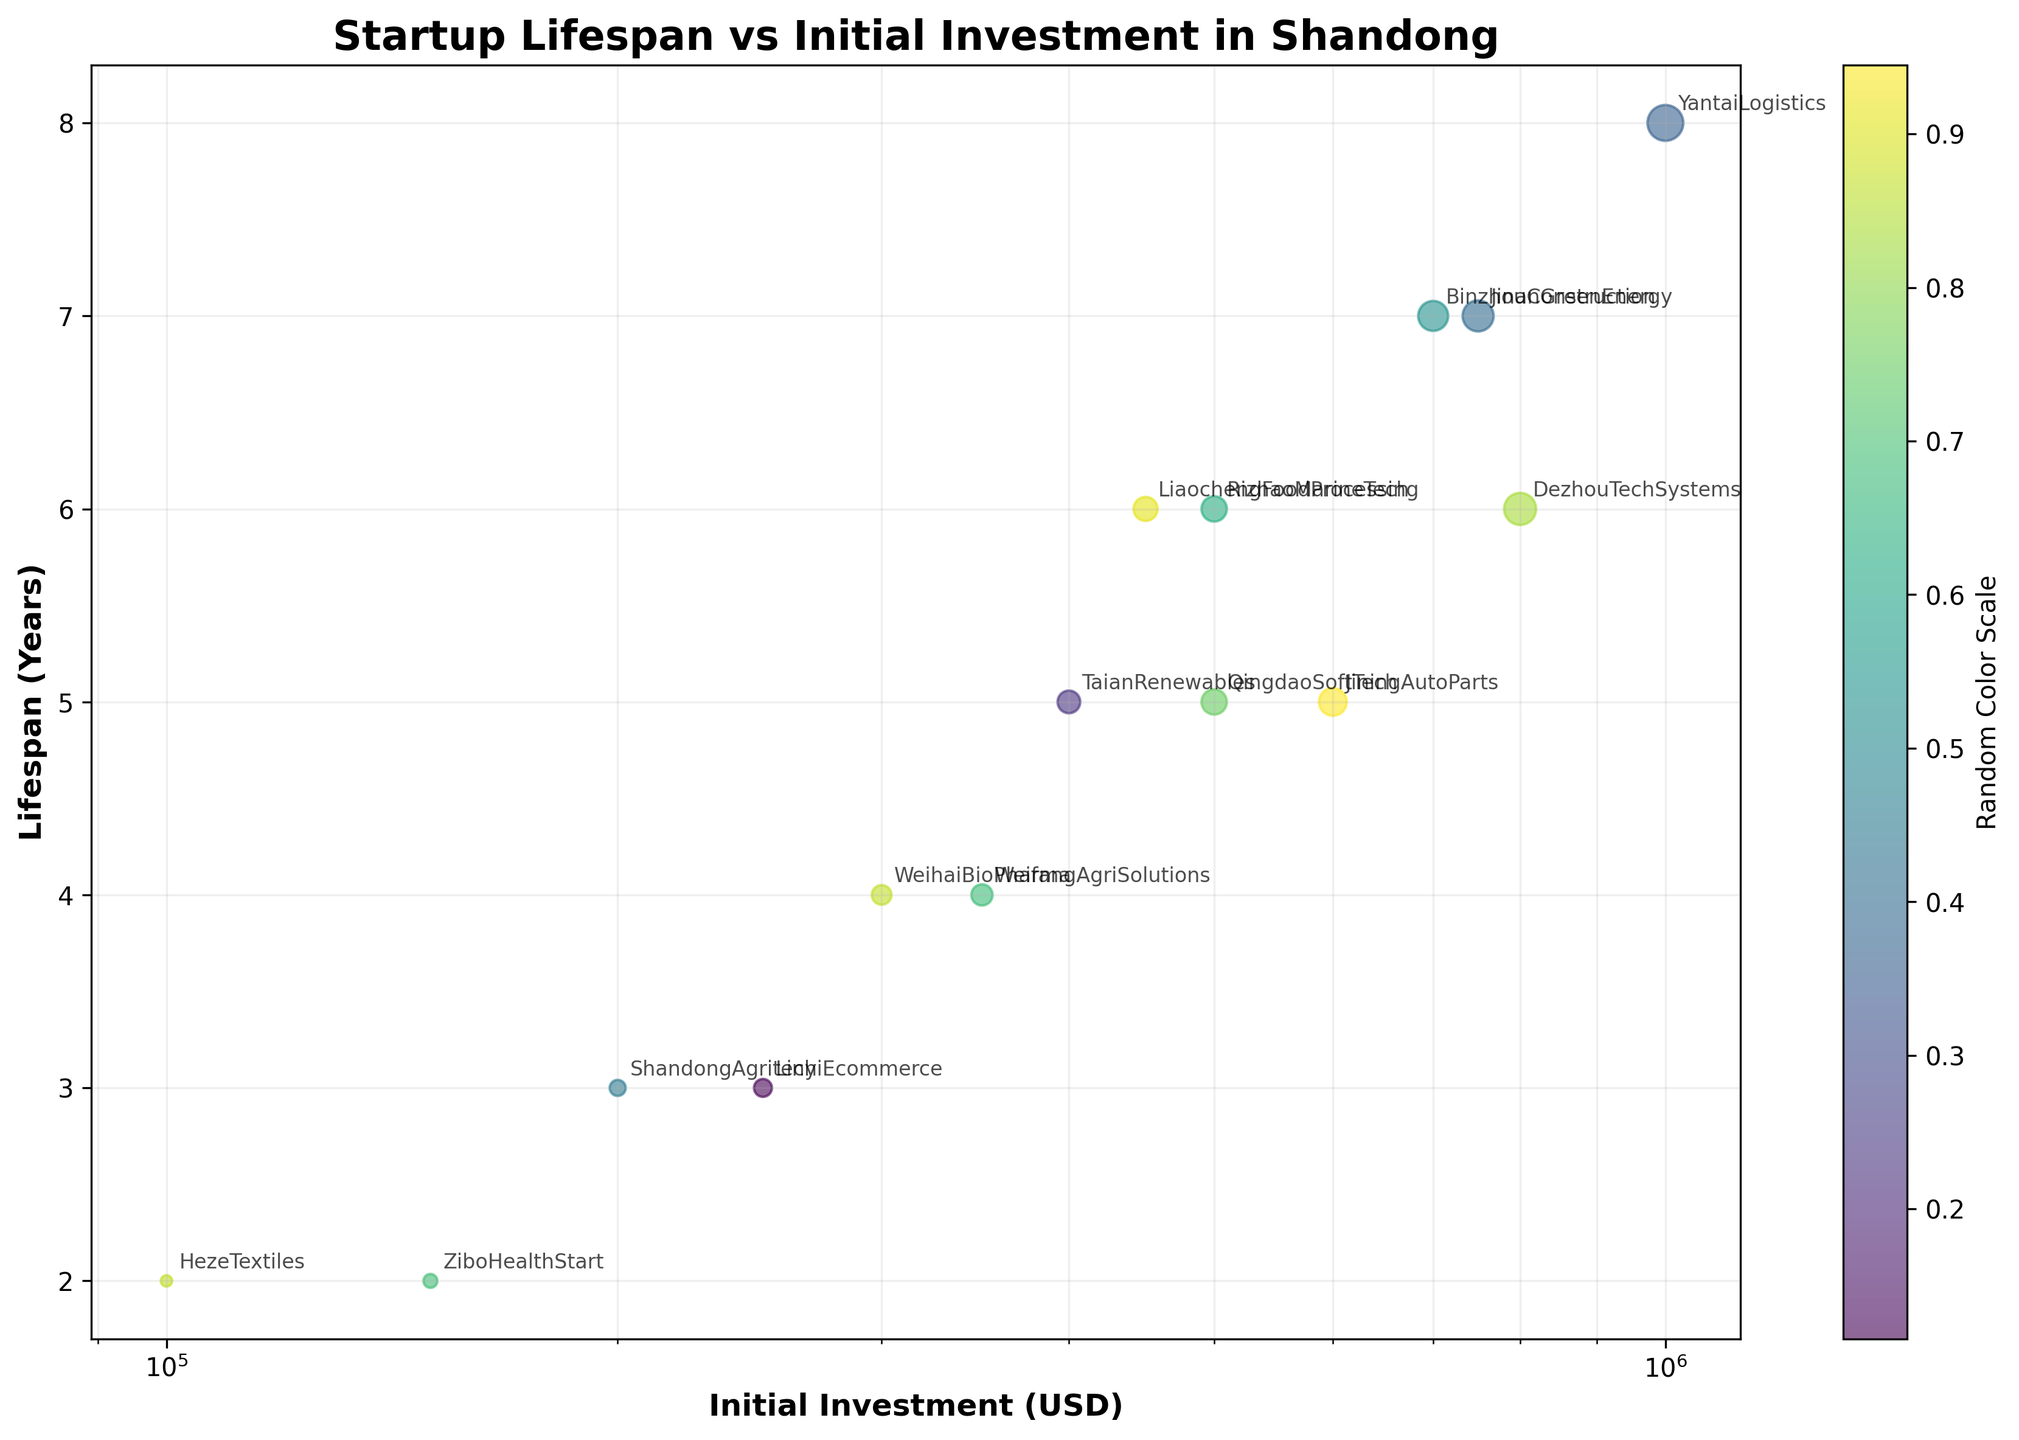What is the title of the scatter plot? The title of the scatter plot is displayed at the top center of the figure. It provides an overview of what the scatter plot represents.
Answer: Startup Lifespan vs Initial Investment in Shandong Which company has the highest initial investment, and what is its lifespan? Identify the company with the highest value on the x-axis (Initial Investment). It is located at the far right on the log scale. Annotate the corresponding y-coordinate (Lifespan).
Answer: YantaiLogistics, 8 years How many companies have an initial investment greater than $500,000? Look for data points to the right of the $500,000 mark on the x-axis (Initial Investment) and count them.
Answer: 9 Which company has the shortest lifespan, and what is its initial investment? Find the company with the lowest value on the y-axis (Lifespan). Annotate the corresponding x-coordinate (Initial Investment).
Answer: HezeTextiles, $100,000 What is the relationship between initial investment and lifespan among the startup companies in Shandong? Observe the general trend of the data points from left to right. Notice if the lifespan tends to increase or decrease with higher initial investment.
Answer: Positive correlation How many companies have a lifespan of more than 5 years? Count the data points above the 5-year mark on the y-axis (Lifespan).
Answer: 8 Which company has the lowest initial investment, and what is its lifespan? Find the company with the lowest value on the x-axis (Initial Investment) and annotate the corresponding y-coordinate (Lifespan).
Answer: HezeTextiles, 2 years Is there a noticeable trend in how the lifespan changes with increasing initial investment? Observe the pattern of data points as the initial investment increases along the x-axis. Determine if there is a systematic increase, decrease, or no clear trend in lifespan.
Answer: Lifespan generally increases Compare the lifespan of WeihaiBioPharma and TaianRenewables. Which one is greater? Locate the data points for WeihaiBioPharma and TaianRenewables on the y-axis and compare their y-coordinates (Lifespan).
Answer: TaianRenewables 